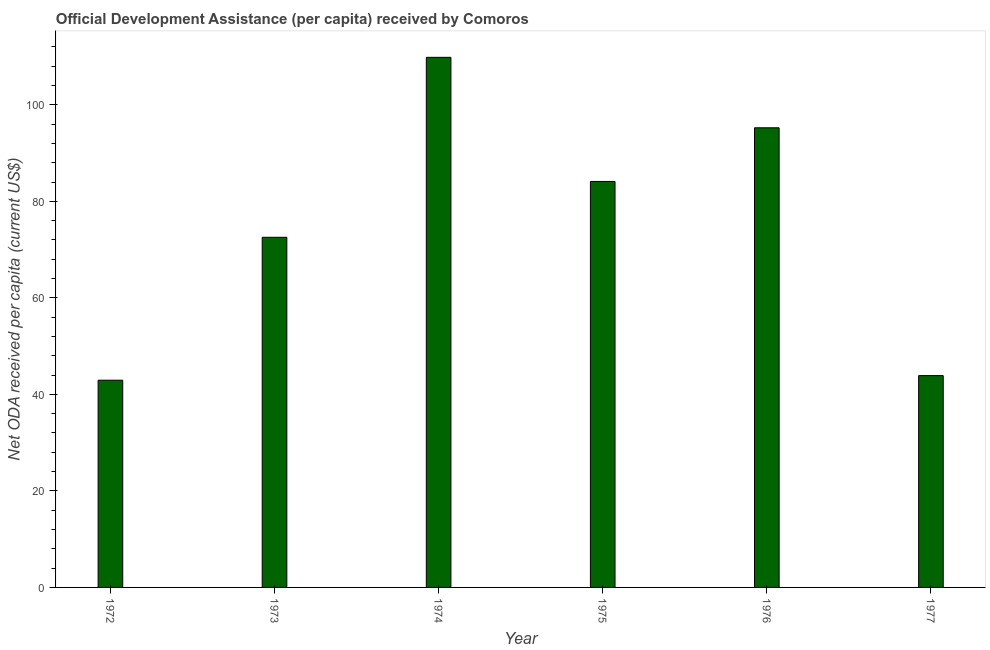Does the graph contain any zero values?
Make the answer very short. No. Does the graph contain grids?
Your response must be concise. No. What is the title of the graph?
Your response must be concise. Official Development Assistance (per capita) received by Comoros. What is the label or title of the Y-axis?
Your response must be concise. Net ODA received per capita (current US$). What is the net oda received per capita in 1976?
Your answer should be compact. 95.24. Across all years, what is the maximum net oda received per capita?
Offer a very short reply. 109.83. Across all years, what is the minimum net oda received per capita?
Keep it short and to the point. 42.94. In which year was the net oda received per capita maximum?
Provide a short and direct response. 1974. In which year was the net oda received per capita minimum?
Give a very brief answer. 1972. What is the sum of the net oda received per capita?
Keep it short and to the point. 448.56. What is the difference between the net oda received per capita in 1976 and 1977?
Give a very brief answer. 51.35. What is the average net oda received per capita per year?
Your answer should be very brief. 74.76. What is the median net oda received per capita?
Your response must be concise. 78.33. In how many years, is the net oda received per capita greater than 52 US$?
Keep it short and to the point. 4. What is the ratio of the net oda received per capita in 1973 to that in 1975?
Make the answer very short. 0.86. Is the net oda received per capita in 1975 less than that in 1977?
Make the answer very short. No. Is the difference between the net oda received per capita in 1973 and 1977 greater than the difference between any two years?
Your answer should be very brief. No. What is the difference between the highest and the second highest net oda received per capita?
Your answer should be very brief. 14.6. Is the sum of the net oda received per capita in 1973 and 1976 greater than the maximum net oda received per capita across all years?
Keep it short and to the point. Yes. What is the difference between the highest and the lowest net oda received per capita?
Your answer should be very brief. 66.9. Are all the bars in the graph horizontal?
Provide a succinct answer. No. What is the difference between two consecutive major ticks on the Y-axis?
Your response must be concise. 20. Are the values on the major ticks of Y-axis written in scientific E-notation?
Keep it short and to the point. No. What is the Net ODA received per capita (current US$) of 1972?
Your answer should be compact. 42.94. What is the Net ODA received per capita (current US$) of 1973?
Provide a succinct answer. 72.55. What is the Net ODA received per capita (current US$) in 1974?
Provide a succinct answer. 109.83. What is the Net ODA received per capita (current US$) in 1975?
Your response must be concise. 84.12. What is the Net ODA received per capita (current US$) in 1976?
Your answer should be very brief. 95.24. What is the Net ODA received per capita (current US$) of 1977?
Your response must be concise. 43.88. What is the difference between the Net ODA received per capita (current US$) in 1972 and 1973?
Ensure brevity in your answer.  -29.61. What is the difference between the Net ODA received per capita (current US$) in 1972 and 1974?
Your response must be concise. -66.9. What is the difference between the Net ODA received per capita (current US$) in 1972 and 1975?
Make the answer very short. -41.18. What is the difference between the Net ODA received per capita (current US$) in 1972 and 1976?
Provide a short and direct response. -52.3. What is the difference between the Net ODA received per capita (current US$) in 1972 and 1977?
Keep it short and to the point. -0.95. What is the difference between the Net ODA received per capita (current US$) in 1973 and 1974?
Provide a succinct answer. -37.29. What is the difference between the Net ODA received per capita (current US$) in 1973 and 1975?
Your answer should be compact. -11.57. What is the difference between the Net ODA received per capita (current US$) in 1973 and 1976?
Provide a short and direct response. -22.69. What is the difference between the Net ODA received per capita (current US$) in 1973 and 1977?
Your response must be concise. 28.66. What is the difference between the Net ODA received per capita (current US$) in 1974 and 1975?
Provide a short and direct response. 25.72. What is the difference between the Net ODA received per capita (current US$) in 1974 and 1976?
Offer a terse response. 14.6. What is the difference between the Net ODA received per capita (current US$) in 1974 and 1977?
Keep it short and to the point. 65.95. What is the difference between the Net ODA received per capita (current US$) in 1975 and 1976?
Your answer should be very brief. -11.12. What is the difference between the Net ODA received per capita (current US$) in 1975 and 1977?
Offer a very short reply. 40.23. What is the difference between the Net ODA received per capita (current US$) in 1976 and 1977?
Your answer should be compact. 51.35. What is the ratio of the Net ODA received per capita (current US$) in 1972 to that in 1973?
Provide a short and direct response. 0.59. What is the ratio of the Net ODA received per capita (current US$) in 1972 to that in 1974?
Make the answer very short. 0.39. What is the ratio of the Net ODA received per capita (current US$) in 1972 to that in 1975?
Your answer should be compact. 0.51. What is the ratio of the Net ODA received per capita (current US$) in 1972 to that in 1976?
Give a very brief answer. 0.45. What is the ratio of the Net ODA received per capita (current US$) in 1973 to that in 1974?
Give a very brief answer. 0.66. What is the ratio of the Net ODA received per capita (current US$) in 1973 to that in 1975?
Your answer should be compact. 0.86. What is the ratio of the Net ODA received per capita (current US$) in 1973 to that in 1976?
Your answer should be very brief. 0.76. What is the ratio of the Net ODA received per capita (current US$) in 1973 to that in 1977?
Ensure brevity in your answer.  1.65. What is the ratio of the Net ODA received per capita (current US$) in 1974 to that in 1975?
Offer a terse response. 1.31. What is the ratio of the Net ODA received per capita (current US$) in 1974 to that in 1976?
Ensure brevity in your answer.  1.15. What is the ratio of the Net ODA received per capita (current US$) in 1974 to that in 1977?
Give a very brief answer. 2.5. What is the ratio of the Net ODA received per capita (current US$) in 1975 to that in 1976?
Provide a short and direct response. 0.88. What is the ratio of the Net ODA received per capita (current US$) in 1975 to that in 1977?
Offer a very short reply. 1.92. What is the ratio of the Net ODA received per capita (current US$) in 1976 to that in 1977?
Ensure brevity in your answer.  2.17. 